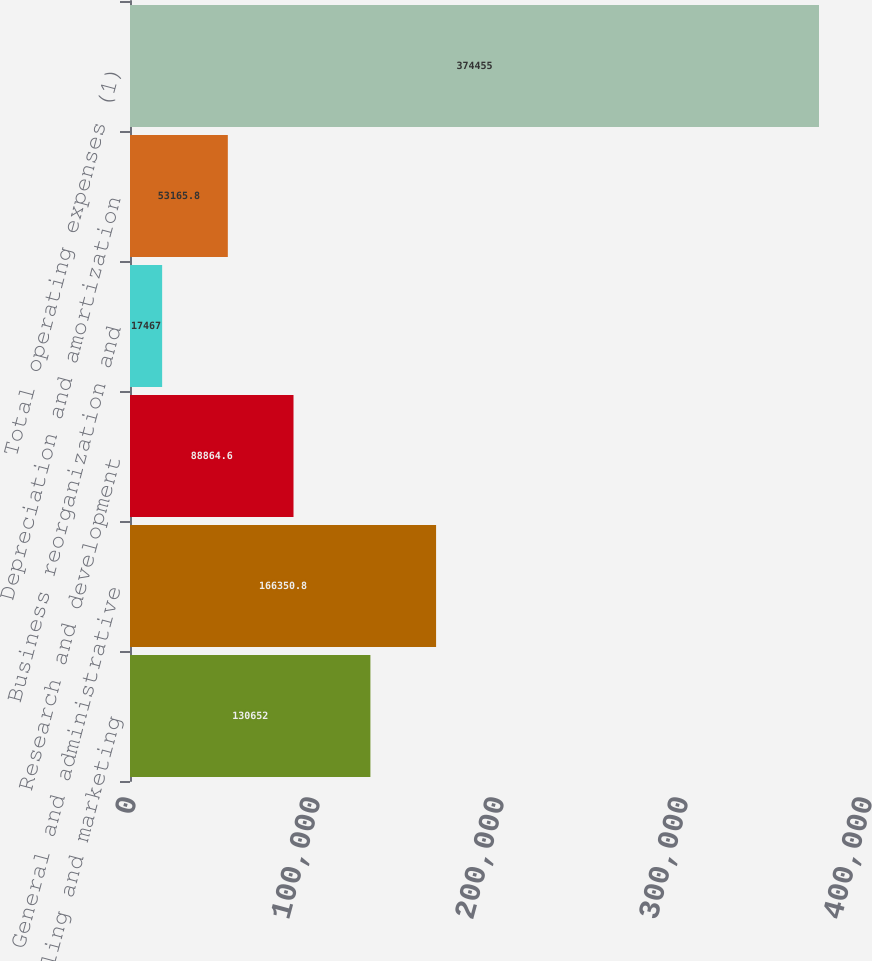<chart> <loc_0><loc_0><loc_500><loc_500><bar_chart><fcel>Selling and marketing<fcel>General and administrative<fcel>Research and development<fcel>Business reorganization and<fcel>Depreciation and amortization<fcel>Total operating expenses (1)<nl><fcel>130652<fcel>166351<fcel>88864.6<fcel>17467<fcel>53165.8<fcel>374455<nl></chart> 